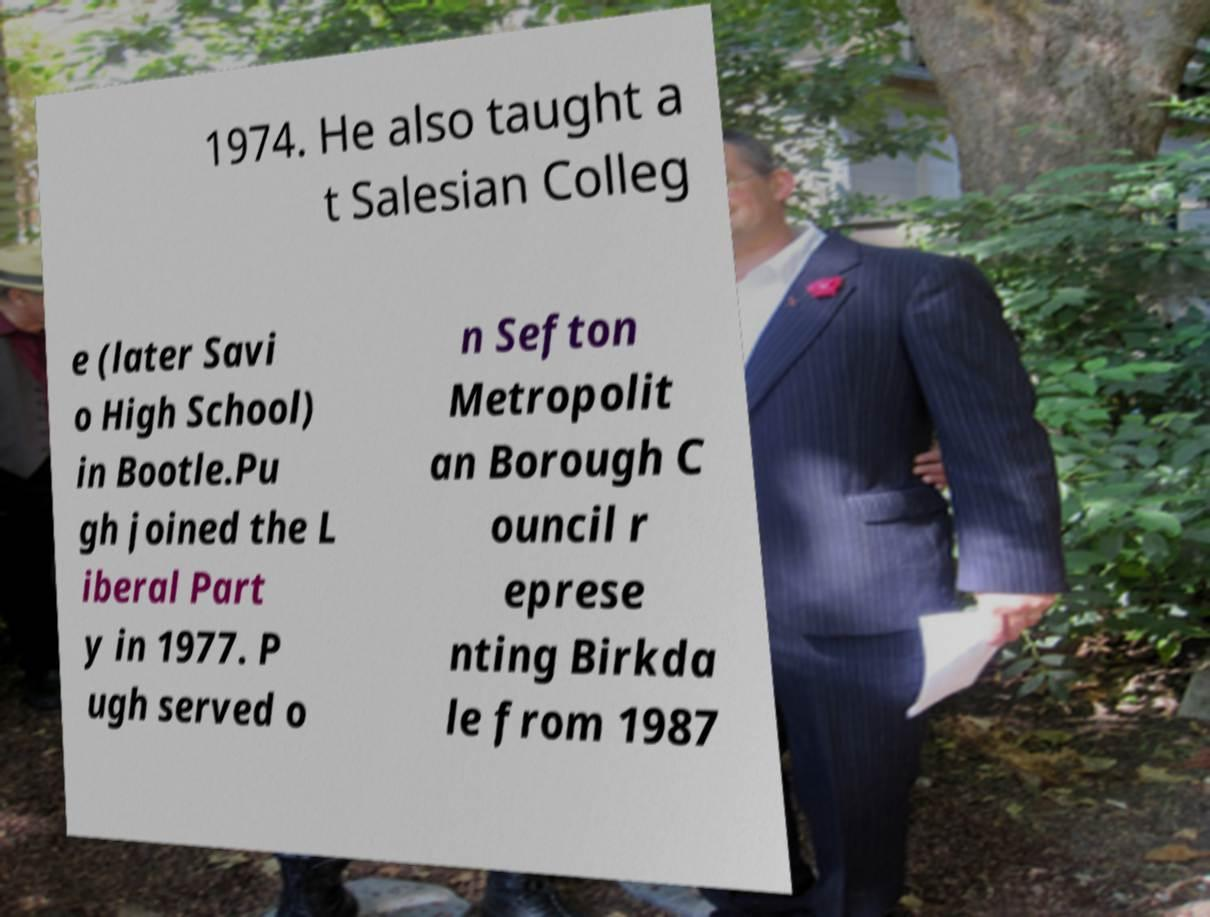Please read and relay the text visible in this image. What does it say? 1974. He also taught a t Salesian Colleg e (later Savi o High School) in Bootle.Pu gh joined the L iberal Part y in 1977. P ugh served o n Sefton Metropolit an Borough C ouncil r eprese nting Birkda le from 1987 